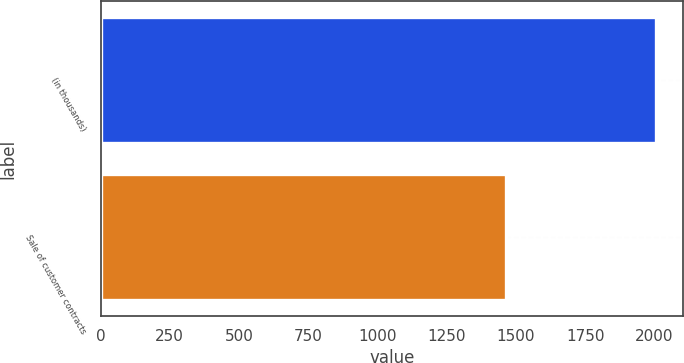Convert chart. <chart><loc_0><loc_0><loc_500><loc_500><bar_chart><fcel>(in thousands)<fcel>Sale of customer contracts<nl><fcel>2005<fcel>1465<nl></chart> 